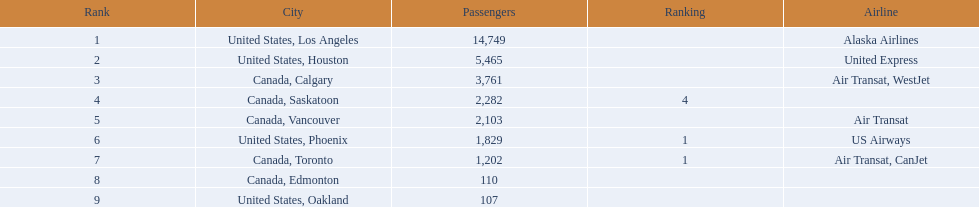What places can one reach from this airport? United States, Los Angeles, United States, Houston, Canada, Calgary, Canada, Saskatoon, Canada, Vancouver, United States, Phoenix, Canada, Toronto, Canada, Edmonton, United States, Oakland. How many travelers are heading to phoenix? 1,829. 